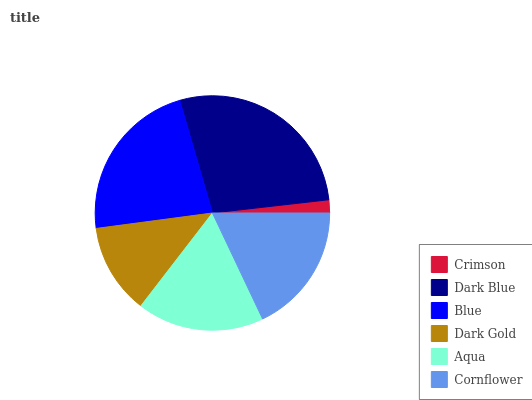Is Crimson the minimum?
Answer yes or no. Yes. Is Dark Blue the maximum?
Answer yes or no. Yes. Is Blue the minimum?
Answer yes or no. No. Is Blue the maximum?
Answer yes or no. No. Is Dark Blue greater than Blue?
Answer yes or no. Yes. Is Blue less than Dark Blue?
Answer yes or no. Yes. Is Blue greater than Dark Blue?
Answer yes or no. No. Is Dark Blue less than Blue?
Answer yes or no. No. Is Cornflower the high median?
Answer yes or no. Yes. Is Aqua the low median?
Answer yes or no. Yes. Is Aqua the high median?
Answer yes or no. No. Is Crimson the low median?
Answer yes or no. No. 